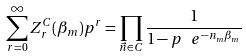Convert formula to latex. <formula><loc_0><loc_0><loc_500><loc_500>\sum _ { r = 0 } ^ { \infty } Z ^ { C } _ { r } ( \beta _ { m } ) p ^ { r } = \prod _ { { \vec { n } } \in C } \frac { 1 } { 1 - p \, \ e ^ { - n _ { m } \beta _ { m } } }</formula> 